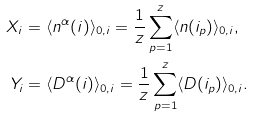Convert formula to latex. <formula><loc_0><loc_0><loc_500><loc_500>X _ { i } & = \langle n ^ { \alpha } ( i ) \rangle _ { 0 , i } = \frac { 1 } { z } \sum _ { p = 1 } ^ { z } \langle n ( i _ { p } ) \rangle _ { 0 , i } , \\ Y _ { i } & = \langle D ^ { \alpha } ( i ) \rangle _ { 0 , i } = \frac { 1 } { z } \sum _ { p = 1 } ^ { z } \langle D ( i _ { p } ) \rangle _ { 0 , i } .</formula> 